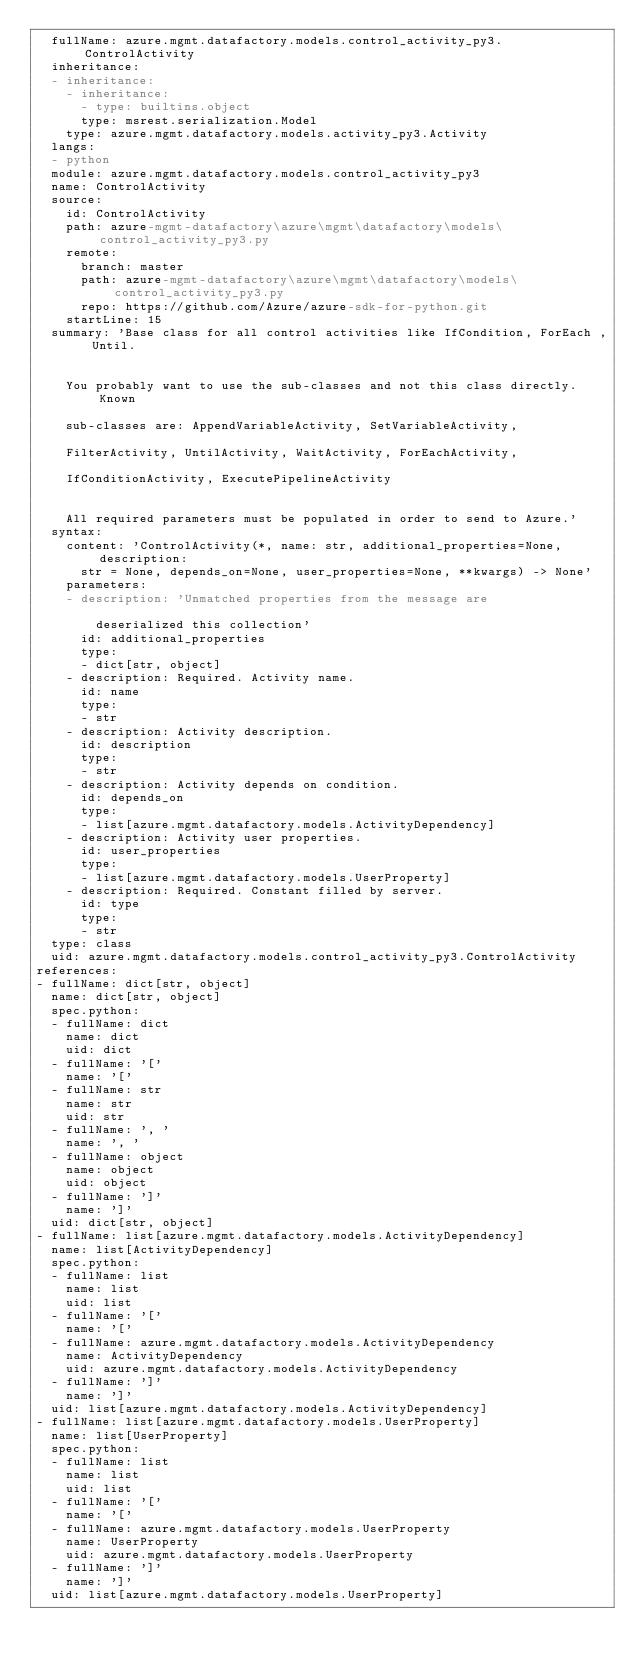<code> <loc_0><loc_0><loc_500><loc_500><_YAML_>  fullName: azure.mgmt.datafactory.models.control_activity_py3.ControlActivity
  inheritance:
  - inheritance:
    - inheritance:
      - type: builtins.object
      type: msrest.serialization.Model
    type: azure.mgmt.datafactory.models.activity_py3.Activity
  langs:
  - python
  module: azure.mgmt.datafactory.models.control_activity_py3
  name: ControlActivity
  source:
    id: ControlActivity
    path: azure-mgmt-datafactory\azure\mgmt\datafactory\models\control_activity_py3.py
    remote:
      branch: master
      path: azure-mgmt-datafactory\azure\mgmt\datafactory\models\control_activity_py3.py
      repo: https://github.com/Azure/azure-sdk-for-python.git
    startLine: 15
  summary: 'Base class for all control activities like IfCondition, ForEach , Until.


    You probably want to use the sub-classes and not this class directly. Known

    sub-classes are: AppendVariableActivity, SetVariableActivity,

    FilterActivity, UntilActivity, WaitActivity, ForEachActivity,

    IfConditionActivity, ExecutePipelineActivity


    All required parameters must be populated in order to send to Azure.'
  syntax:
    content: 'ControlActivity(*, name: str, additional_properties=None, description:
      str = None, depends_on=None, user_properties=None, **kwargs) -> None'
    parameters:
    - description: 'Unmatched properties from the message are

        deserialized this collection'
      id: additional_properties
      type:
      - dict[str, object]
    - description: Required. Activity name.
      id: name
      type:
      - str
    - description: Activity description.
      id: description
      type:
      - str
    - description: Activity depends on condition.
      id: depends_on
      type:
      - list[azure.mgmt.datafactory.models.ActivityDependency]
    - description: Activity user properties.
      id: user_properties
      type:
      - list[azure.mgmt.datafactory.models.UserProperty]
    - description: Required. Constant filled by server.
      id: type
      type:
      - str
  type: class
  uid: azure.mgmt.datafactory.models.control_activity_py3.ControlActivity
references:
- fullName: dict[str, object]
  name: dict[str, object]
  spec.python:
  - fullName: dict
    name: dict
    uid: dict
  - fullName: '['
    name: '['
  - fullName: str
    name: str
    uid: str
  - fullName: ', '
    name: ', '
  - fullName: object
    name: object
    uid: object
  - fullName: ']'
    name: ']'
  uid: dict[str, object]
- fullName: list[azure.mgmt.datafactory.models.ActivityDependency]
  name: list[ActivityDependency]
  spec.python:
  - fullName: list
    name: list
    uid: list
  - fullName: '['
    name: '['
  - fullName: azure.mgmt.datafactory.models.ActivityDependency
    name: ActivityDependency
    uid: azure.mgmt.datafactory.models.ActivityDependency
  - fullName: ']'
    name: ']'
  uid: list[azure.mgmt.datafactory.models.ActivityDependency]
- fullName: list[azure.mgmt.datafactory.models.UserProperty]
  name: list[UserProperty]
  spec.python:
  - fullName: list
    name: list
    uid: list
  - fullName: '['
    name: '['
  - fullName: azure.mgmt.datafactory.models.UserProperty
    name: UserProperty
    uid: azure.mgmt.datafactory.models.UserProperty
  - fullName: ']'
    name: ']'
  uid: list[azure.mgmt.datafactory.models.UserProperty]
</code> 